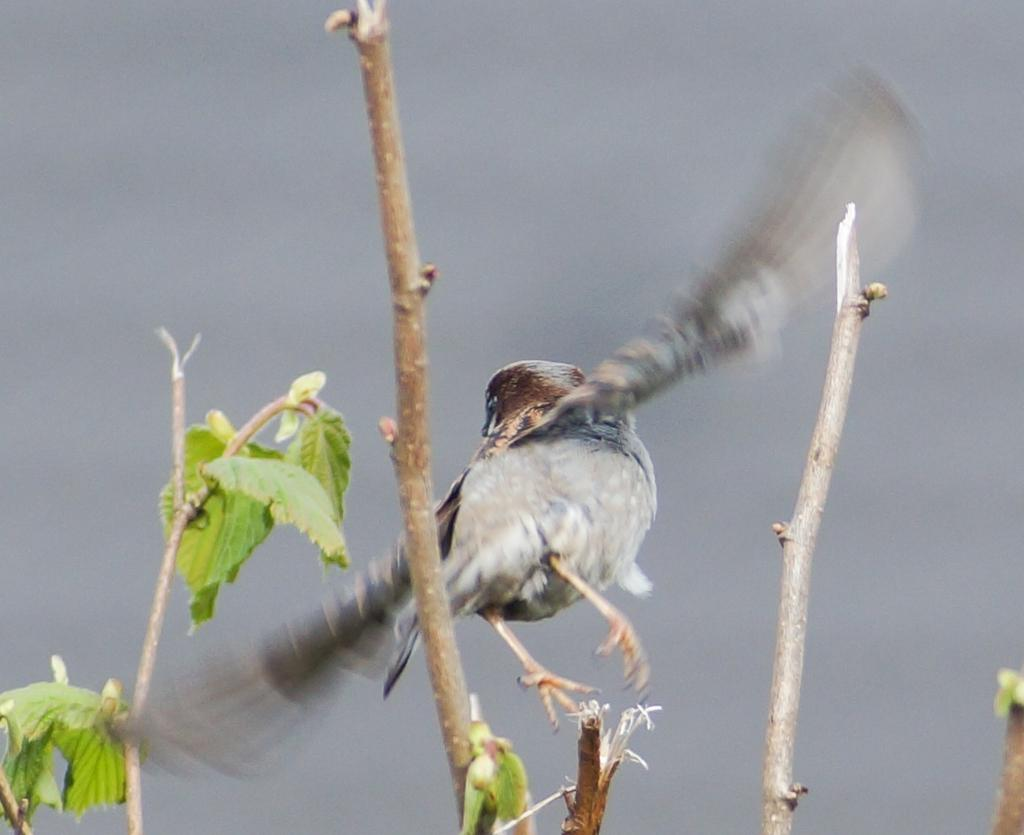What type of animal is in the image? There is a bird in the image. Can you describe the bird's colors? The bird has black, grey, and brown colors. What else can be seen in the image besides the bird? There is a plant in the image. What color are the leaves of the plant? The leaves of the plant are green. What colors are present in the background of the image? The background of the image is white and grey. What type of heart-shaped appliance can be seen in the image? There is no heart-shaped appliance present in the image. Can you describe the insects that are crawling on the bird in the image? There are no insects present in the image; it only features a bird and a plant. 